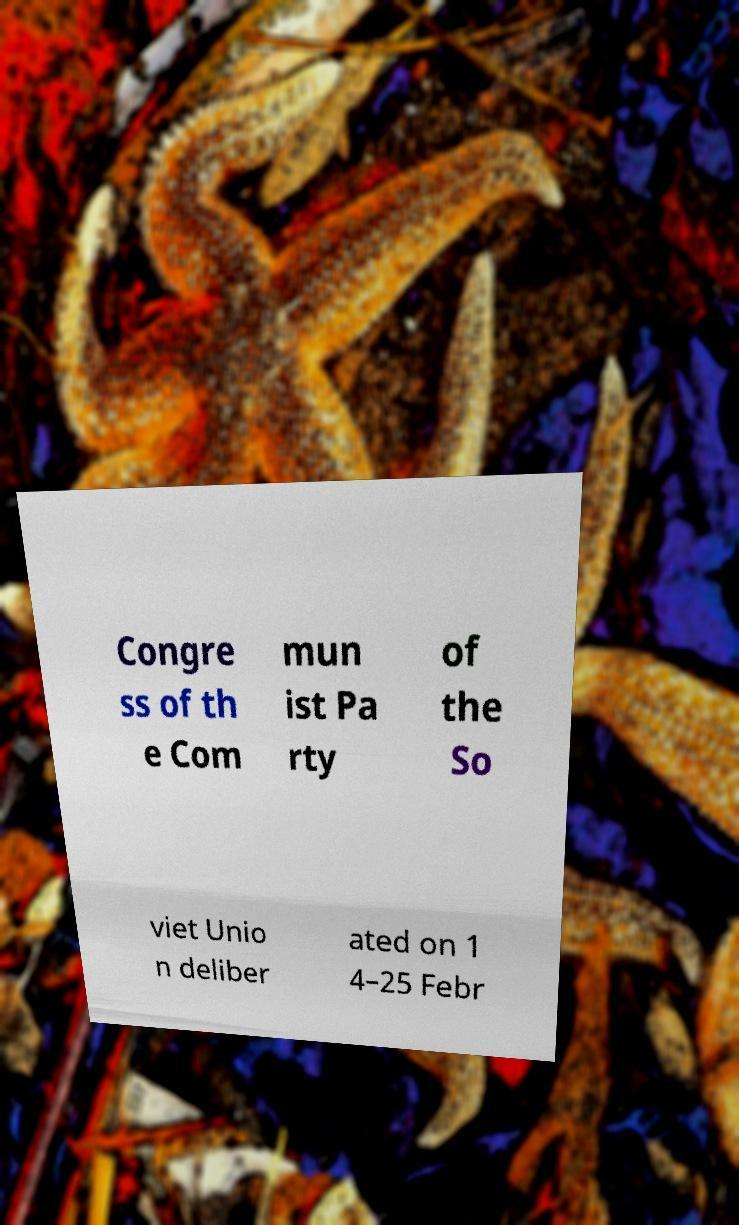There's text embedded in this image that I need extracted. Can you transcribe it verbatim? Congre ss of th e Com mun ist Pa rty of the So viet Unio n deliber ated on 1 4–25 Febr 